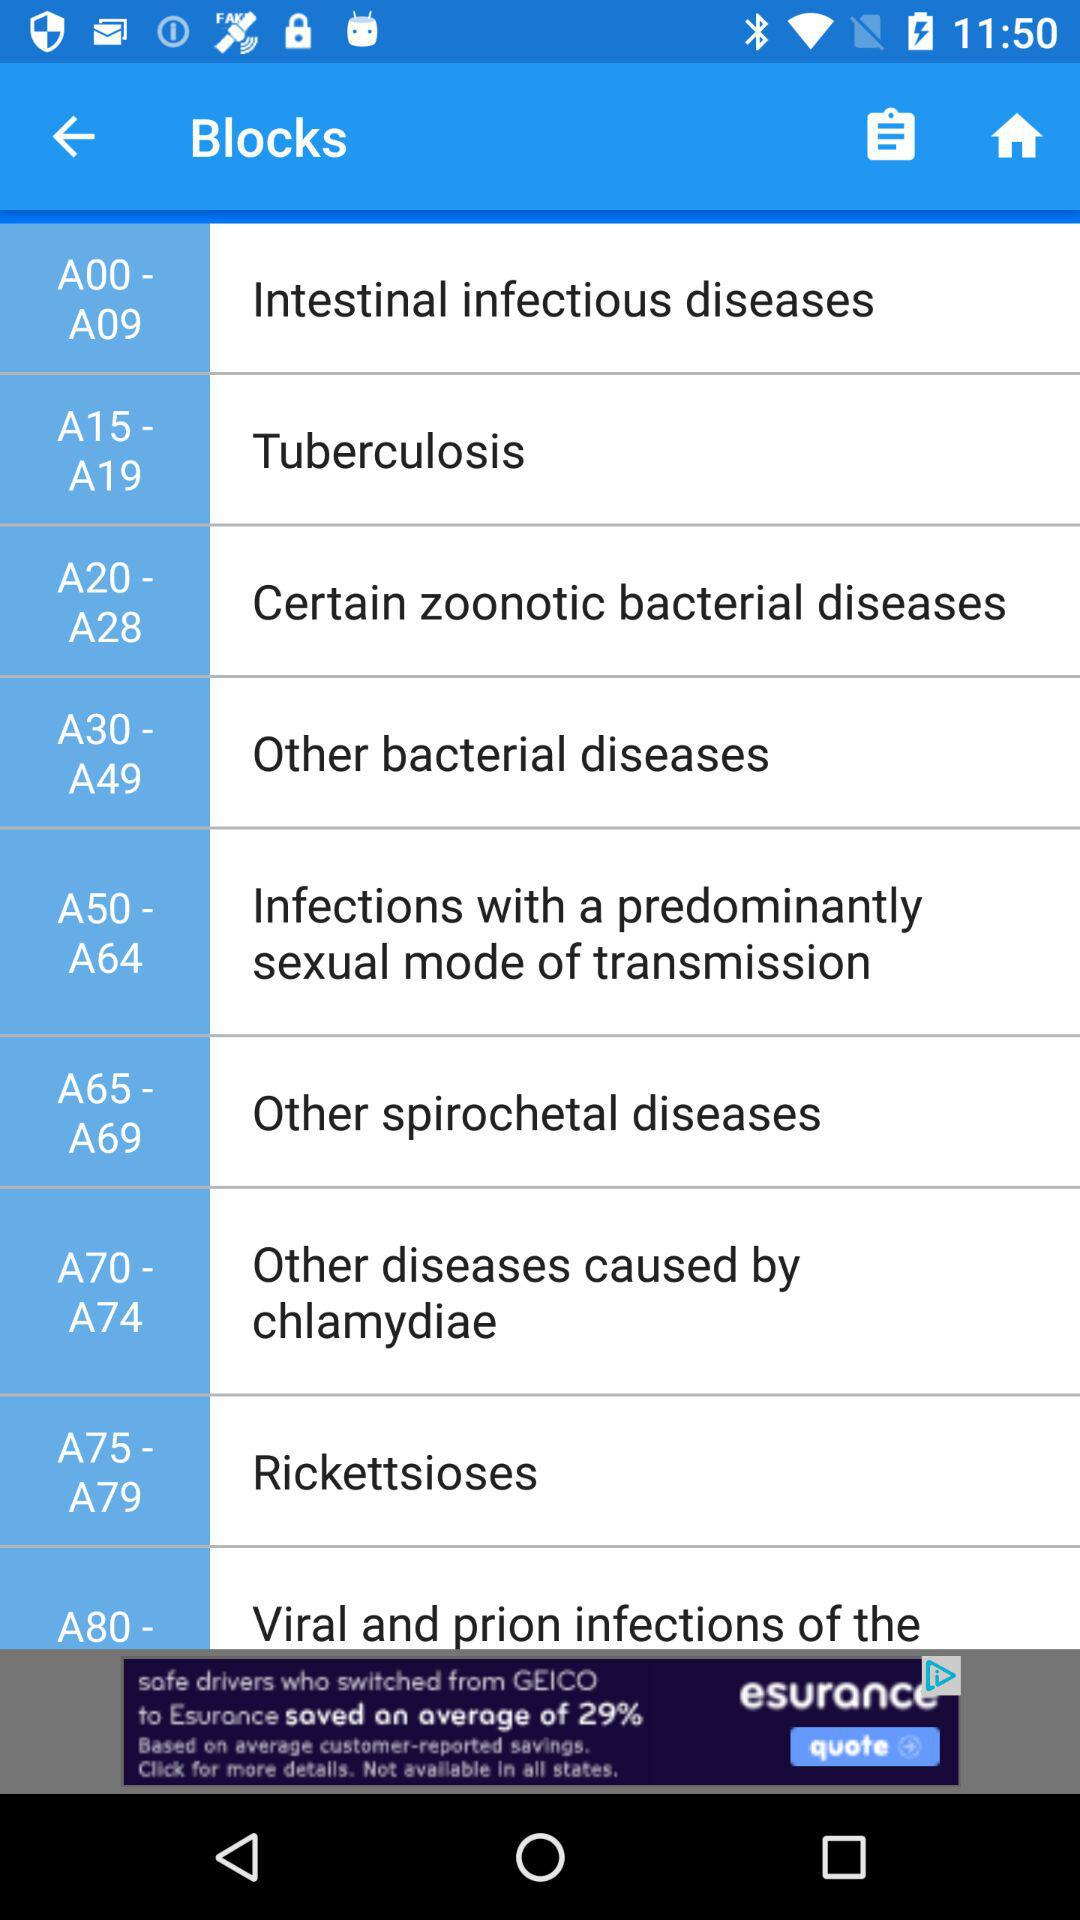Which option is selected?
When the provided information is insufficient, respond with <no answer>. <no answer> 